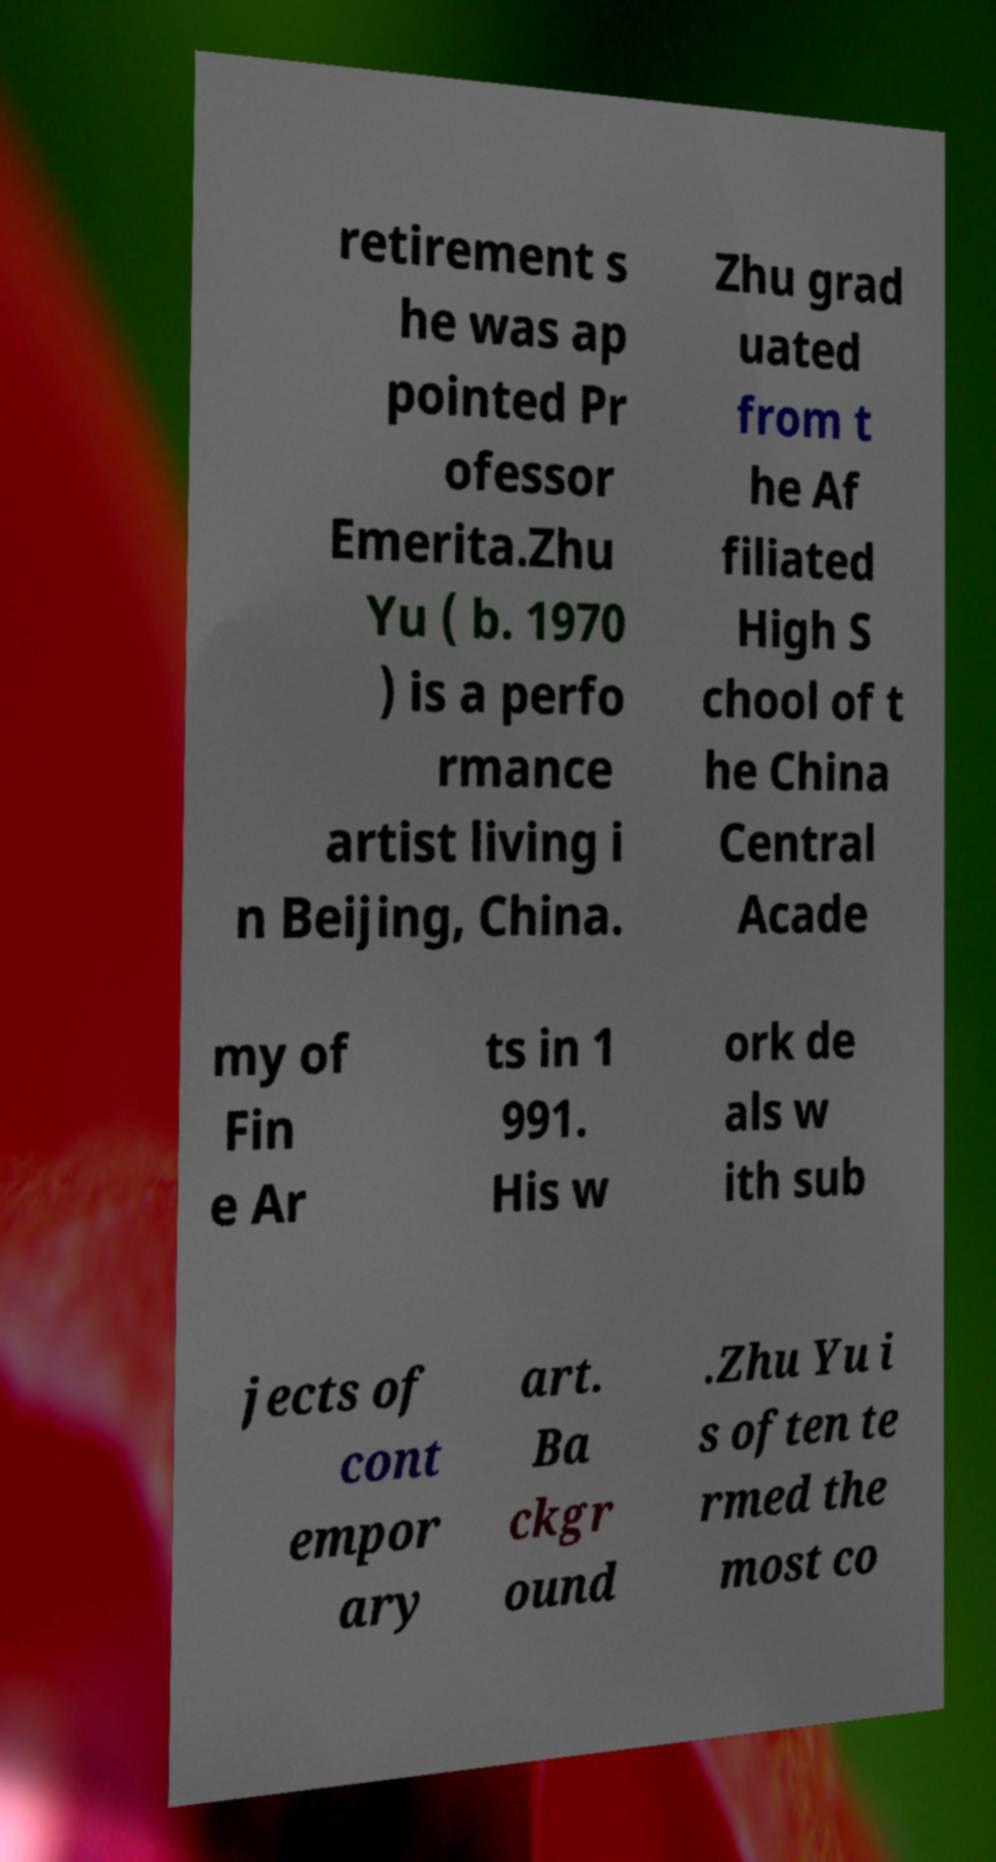Could you extract and type out the text from this image? retirement s he was ap pointed Pr ofessor Emerita.Zhu Yu ( b. 1970 ) is a perfo rmance artist living i n Beijing, China. Zhu grad uated from t he Af filiated High S chool of t he China Central Acade my of Fin e Ar ts in 1 991. His w ork de als w ith sub jects of cont empor ary art. Ba ckgr ound .Zhu Yu i s often te rmed the most co 